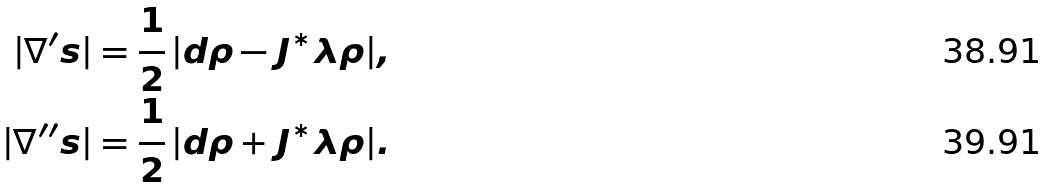<formula> <loc_0><loc_0><loc_500><loc_500>| \nabla ^ { \prime } s | & = \frac { 1 } { 2 } \, | d \rho - J ^ { * } \lambda \rho | , \\ | \nabla ^ { \prime \prime } s | & = \frac { 1 } { 2 } \, | d \rho + J ^ { * } \lambda \rho | .</formula> 